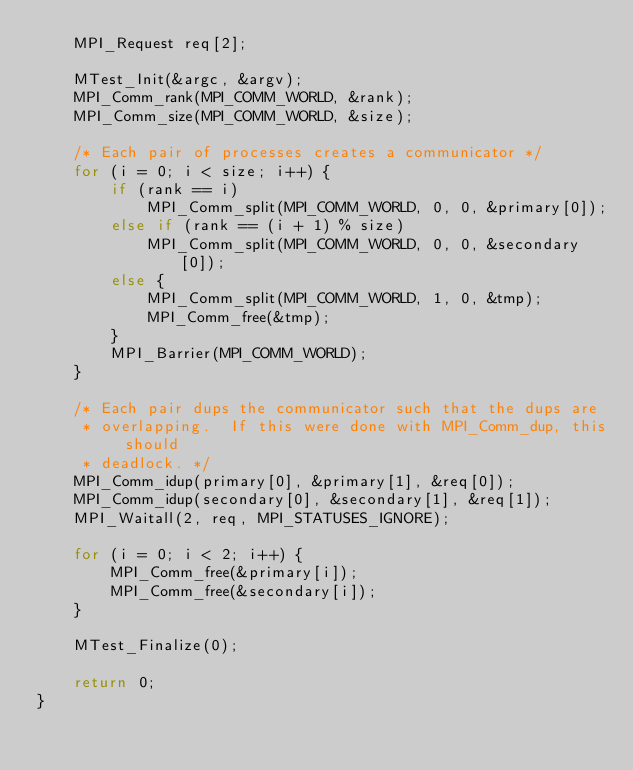Convert code to text. <code><loc_0><loc_0><loc_500><loc_500><_C_>    MPI_Request req[2];

    MTest_Init(&argc, &argv);
    MPI_Comm_rank(MPI_COMM_WORLD, &rank);
    MPI_Comm_size(MPI_COMM_WORLD, &size);

    /* Each pair of processes creates a communicator */
    for (i = 0; i < size; i++) {
        if (rank == i)
            MPI_Comm_split(MPI_COMM_WORLD, 0, 0, &primary[0]);
        else if (rank == (i + 1) % size)
            MPI_Comm_split(MPI_COMM_WORLD, 0, 0, &secondary[0]);
        else {
            MPI_Comm_split(MPI_COMM_WORLD, 1, 0, &tmp);
            MPI_Comm_free(&tmp);
        }
        MPI_Barrier(MPI_COMM_WORLD);
    }

    /* Each pair dups the communicator such that the dups are
     * overlapping.  If this were done with MPI_Comm_dup, this should
     * deadlock. */
    MPI_Comm_idup(primary[0], &primary[1], &req[0]);
    MPI_Comm_idup(secondary[0], &secondary[1], &req[1]);
    MPI_Waitall(2, req, MPI_STATUSES_IGNORE);

    for (i = 0; i < 2; i++) {
        MPI_Comm_free(&primary[i]);
        MPI_Comm_free(&secondary[i]);
    }

    MTest_Finalize(0);

    return 0;
}
</code> 